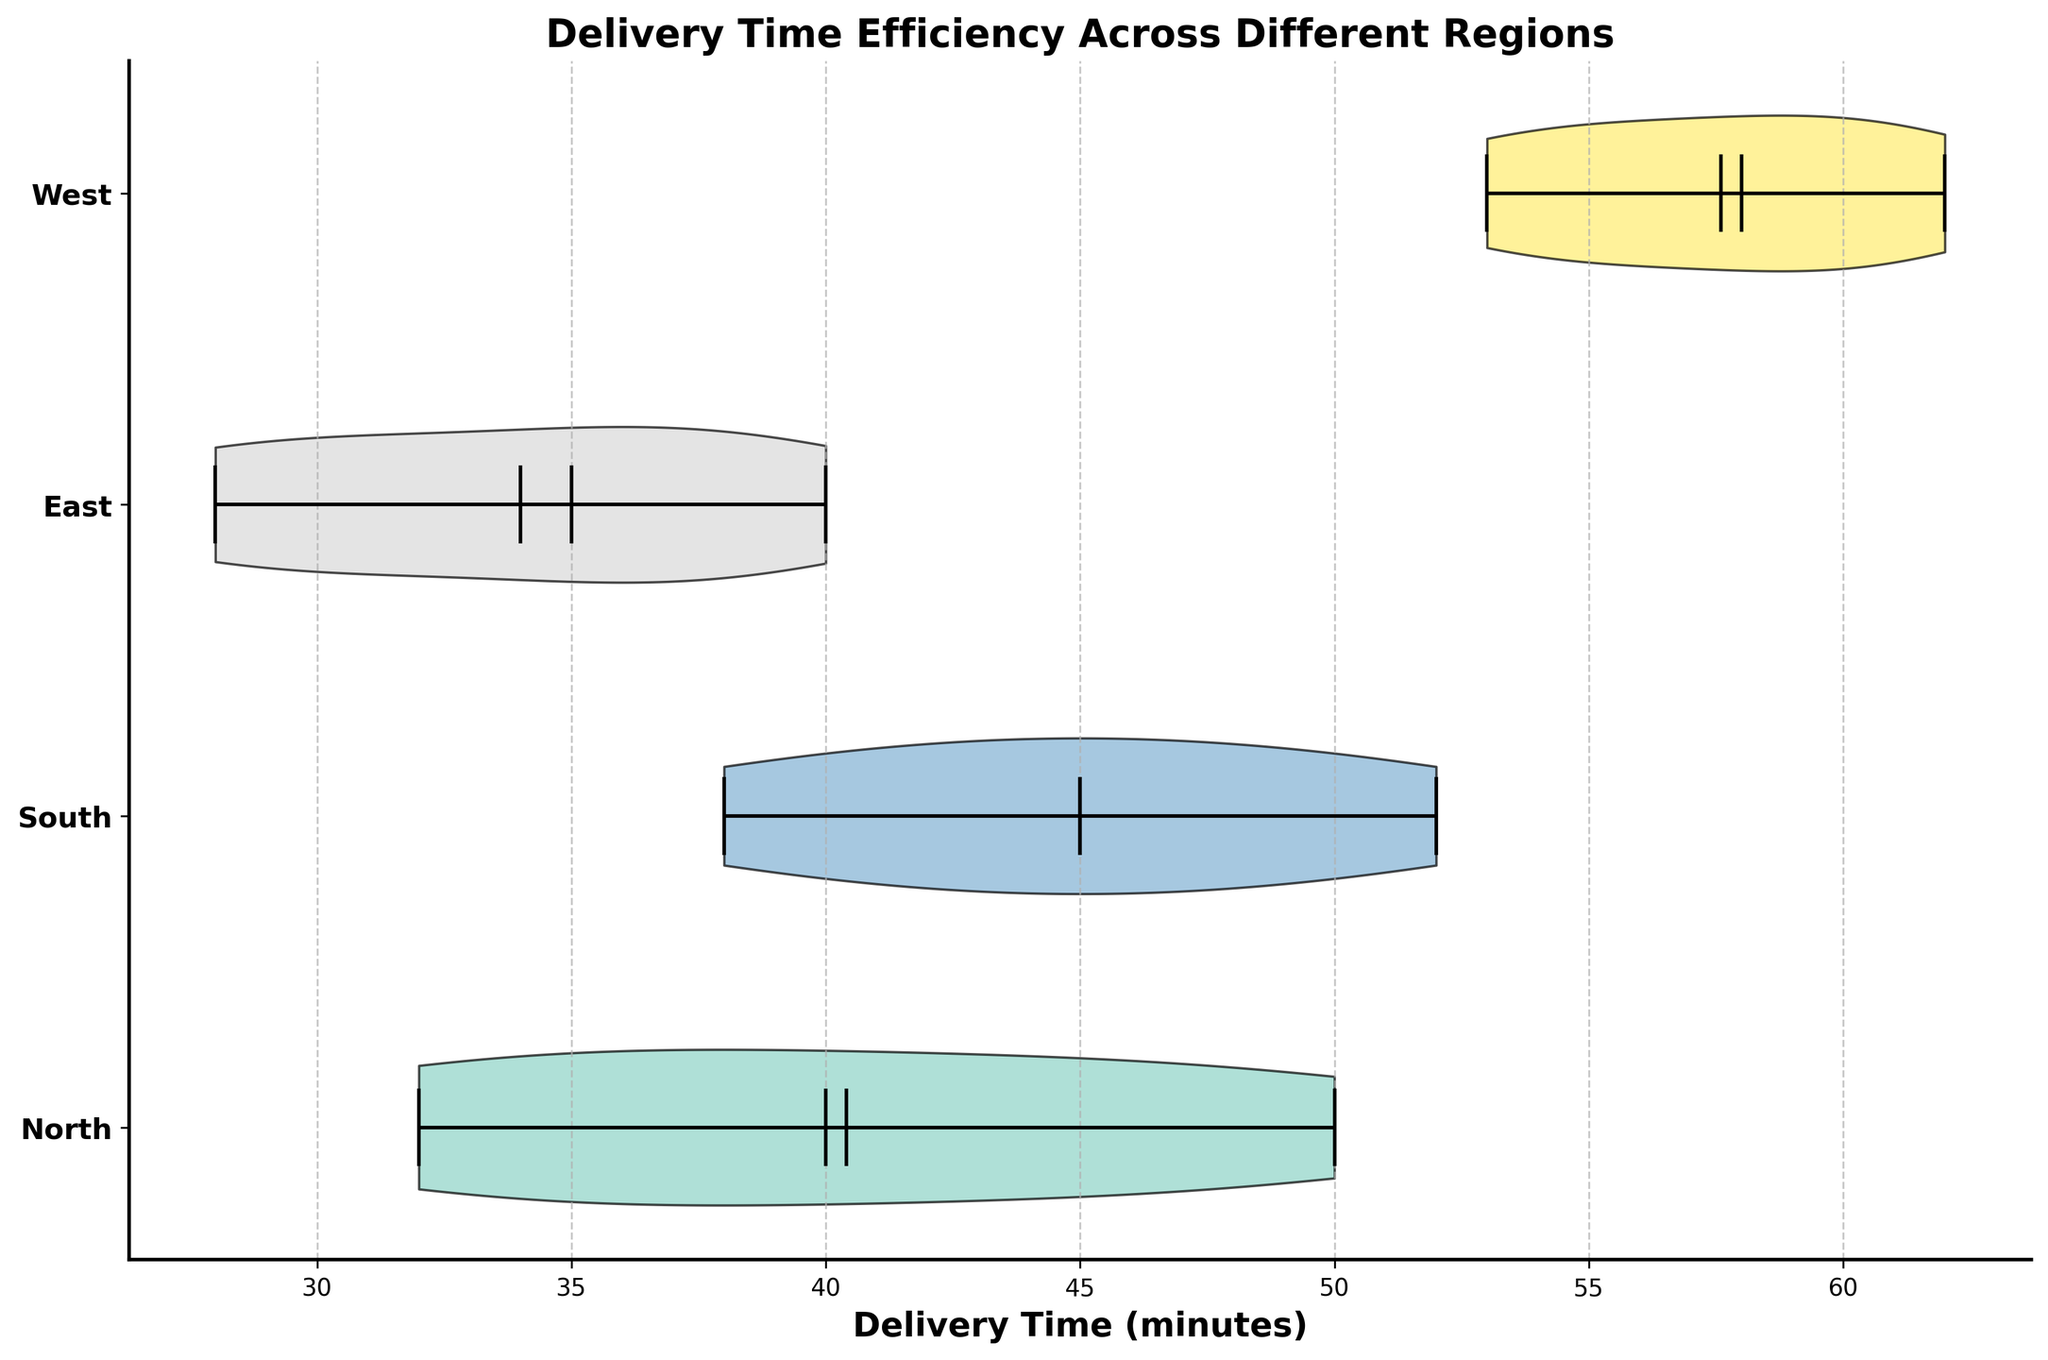What is the title of the figure? The title is located at the top of the chart and summarizes the main focus of the visualization. It reads "Delivery Time Efficiency Across Different Regions."
Answer: Delivery Time Efficiency Across Different Regions How many regions are compared in this figure? The regions are denoted by the y-axis labels. There are four regions listed: North, South, East, and West.
Answer: Four Which region has the longest delivery times? By observing the spread and length of the violins along the x-axis, it is clear that the West region has the longest delivery times, extending from 53 to 62 minutes.
Answer: West What is the mean delivery time for the South region? The mean delivery time for each region is indicated by a white dot within the violin plot. For the South region, this white dot is positioned at 45 minutes.
Answer: 45 minutes Which region has the most variability in delivery times? Variability can be assessed by examining the spread of each violin. The West region shows the widest spread, indicating the most variability in delivery times.
Answer: West How does the median delivery time in the East compare to that in the North? The median delivery time is indicated by a thick black line within each violin. By comparing the lines, the East has a median around 35 minutes, while North has a median close to 40 minutes.
Answer: East's median is lower than North's median What is the maximum delivery time recorded in the South region? The maximum delivery time is marked by the rightmost point of the violin for each region. In the South region, this point is at 52 minutes.
Answer: 52 minutes How does the distribution of delivery times in the North region appear? The North region's delivery times distribution is relatively symmetrical with a concentration around the median, suggesting consistent delivery efficiencies.
Answer: Symmetrical In which region is the interquartile range (IQR) of delivery times the smallest? The IQR is represented by the narrowest part of the violin around the median. The East region has the smallest IQR, indicating lower variability within the middle 50% of the data.
Answer: East What are the color distinctions used in the plot? Each region is represented by a unique color from the colormap, and the bodies of the violins are filled with these colors for visual distinction while keeping the edges black.
Answer: Unique colors 